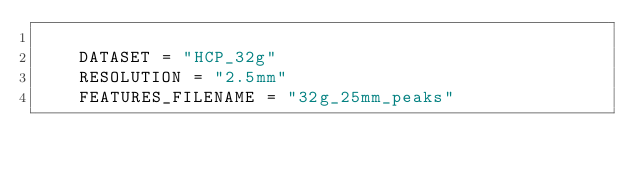Convert code to text. <code><loc_0><loc_0><loc_500><loc_500><_Python_>
    DATASET = "HCP_32g"
    RESOLUTION = "2.5mm"
    FEATURES_FILENAME = "32g_25mm_peaks"</code> 